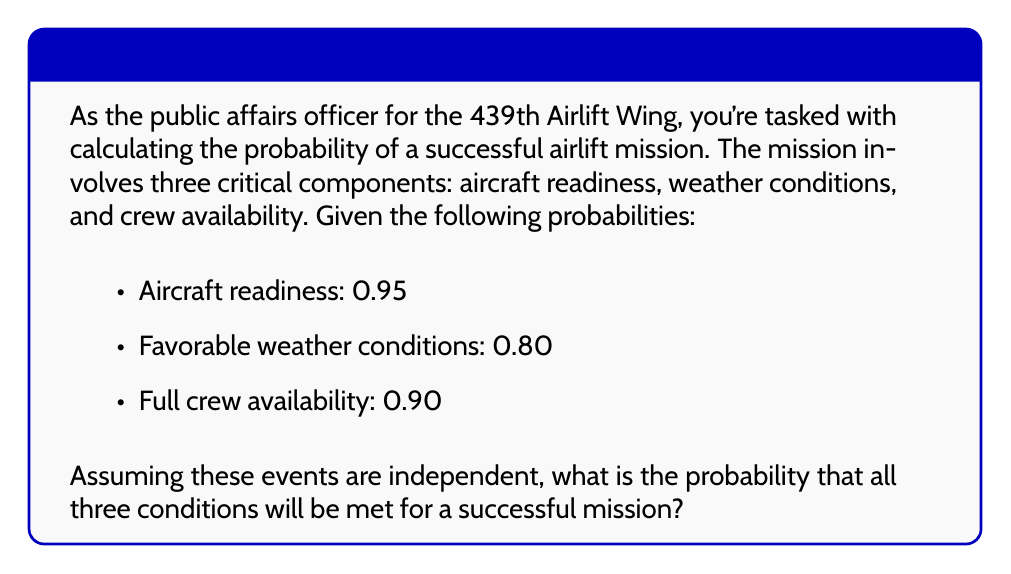Teach me how to tackle this problem. To solve this problem, we need to use the multiplication rule for independent events. Since all three events (aircraft readiness, favorable weather conditions, and full crew availability) must occur simultaneously for the mission to be successful, we multiply their individual probabilities.

Let's define our events:
$A$ = Aircraft readiness
$W$ = Favorable weather conditions
$C$ = Full crew availability

Given:
$P(A) = 0.95$
$P(W) = 0.80$
$P(C) = 0.90$

The probability of all three events occurring together is:

$$P(A \cap W \cap C) = P(A) \times P(W) \times P(C)$$

Substituting the given probabilities:

$$P(A \cap W \cap C) = 0.95 \times 0.80 \times 0.90$$

Calculating:

$$P(A \cap W \cap C) = 0.684$$

Therefore, the probability that all three conditions will be met for a successful mission is 0.684 or 68.4%.
Answer: 0.684 or 68.4% 